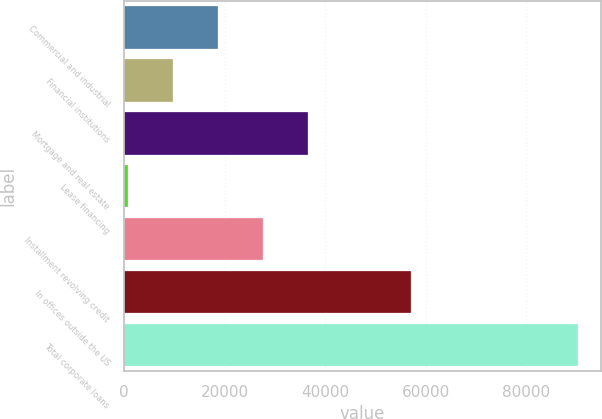Convert chart. <chart><loc_0><loc_0><loc_500><loc_500><bar_chart><fcel>Commercial and industrial<fcel>Financial institutions<fcel>Mortgage and real estate<fcel>Lease financing<fcel>Installment revolving credit<fcel>In offices outside the US<fcel>Total corporate loans<nl><fcel>18602<fcel>9638<fcel>36530<fcel>674<fcel>27566<fcel>56997<fcel>90314<nl></chart> 